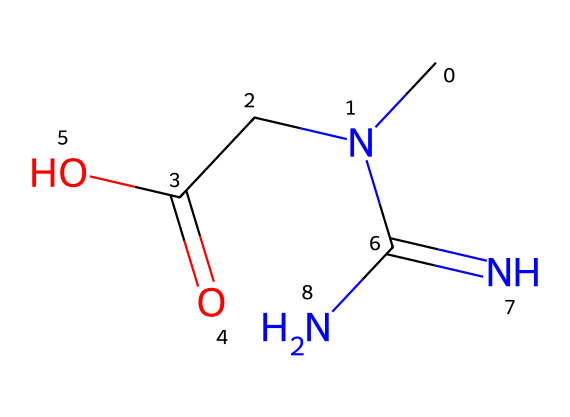What is the molecular formula of creatine? The SMILES representation can be translated into its elemental composition. From the structure, we can identify that there are 4 carbon (C) atoms, 9 hydrogen (H) atoms, 3 nitrogen (N) atoms, and 2 oxygen (O) atoms contributing to the molecular formula. Thus, the formula can be expressed as C4H9N3O2.
Answer: C4H9N3O2 How many nitrogen atoms are present in creatine? By examining the SMILES representation, we can count the nitrogen (N) atoms, which appear in the chemical structure as indicated. In this case, there are 3 nitrogen (N) atoms present in the structure.
Answer: 3 What type of functional groups are found in creatine? Looking at the chemical structure, we can identify functional groups such as the carboxylic acid (COOH) group and the guanidine group (which involves the nitrogen configuration). Thus, the presence of these groups can help in classifying the functional characteristics of creatine.
Answer: carboxylic acid and guanidine Does creatine contain a carboxylic acid group? The presence of a -COOH group in the SMILES representation indicates that creatine has a carboxylic acid functional group. The structure specifically shows the carbon double-bonded to one oxygen and single-bonded to a hydroxyl group.
Answer: yes What is the hybridization state of the carbon atoms in creatine? Analyzing the structure, we recognize that some carbon atoms are bonded to four substituents and thus are sp3 hybridized, while others form double bonds and exhibit sp2 hybridization. In this case, the carbon in the carboxylic acid is sp2 hybridized due to the double bond.
Answer: sp3 and sp2 